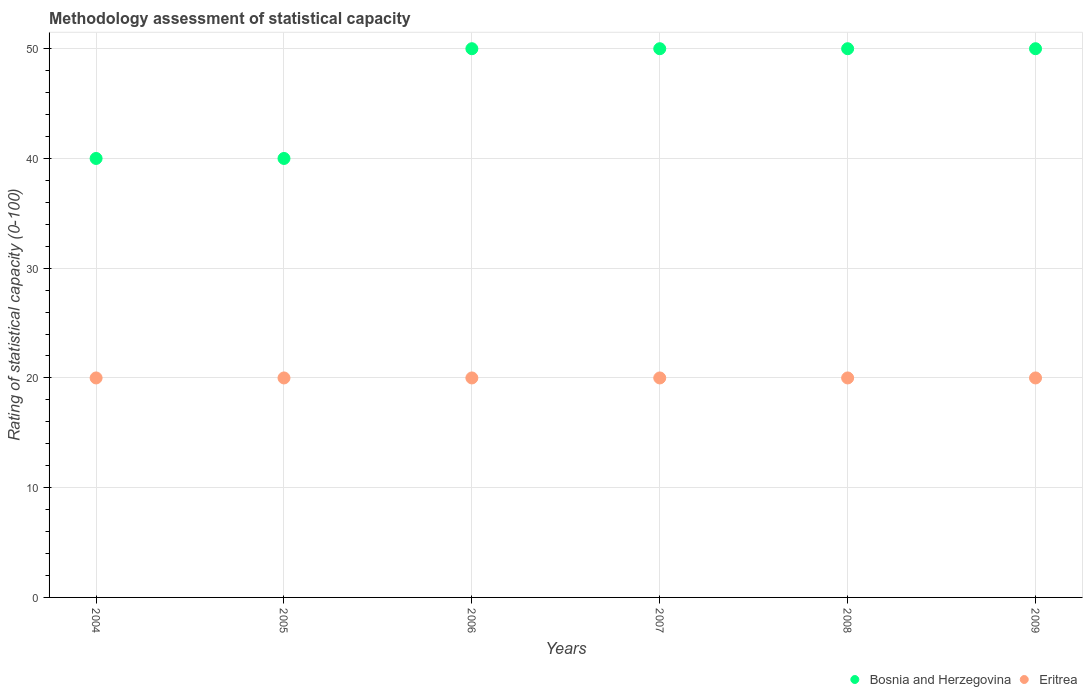How many different coloured dotlines are there?
Make the answer very short. 2. What is the rating of statistical capacity in Bosnia and Herzegovina in 2008?
Your response must be concise. 50. Across all years, what is the maximum rating of statistical capacity in Bosnia and Herzegovina?
Keep it short and to the point. 50. Across all years, what is the minimum rating of statistical capacity in Eritrea?
Provide a succinct answer. 20. In which year was the rating of statistical capacity in Bosnia and Herzegovina maximum?
Provide a short and direct response. 2006. What is the total rating of statistical capacity in Eritrea in the graph?
Offer a very short reply. 120. What is the difference between the rating of statistical capacity in Bosnia and Herzegovina in 2008 and that in 2009?
Offer a terse response. 0. What is the difference between the rating of statistical capacity in Bosnia and Herzegovina in 2004 and the rating of statistical capacity in Eritrea in 2008?
Give a very brief answer. 20. In the year 2004, what is the difference between the rating of statistical capacity in Bosnia and Herzegovina and rating of statistical capacity in Eritrea?
Provide a short and direct response. 20. In how many years, is the rating of statistical capacity in Bosnia and Herzegovina greater than 30?
Provide a succinct answer. 6. What is the ratio of the rating of statistical capacity in Eritrea in 2006 to that in 2008?
Provide a succinct answer. 1. Is the rating of statistical capacity in Eritrea in 2005 less than that in 2008?
Offer a terse response. No. In how many years, is the rating of statistical capacity in Eritrea greater than the average rating of statistical capacity in Eritrea taken over all years?
Offer a very short reply. 0. Does the rating of statistical capacity in Eritrea monotonically increase over the years?
Provide a succinct answer. No. What is the difference between two consecutive major ticks on the Y-axis?
Offer a very short reply. 10. Does the graph contain any zero values?
Make the answer very short. No. Does the graph contain grids?
Give a very brief answer. Yes. Where does the legend appear in the graph?
Offer a terse response. Bottom right. How many legend labels are there?
Provide a short and direct response. 2. What is the title of the graph?
Your answer should be very brief. Methodology assessment of statistical capacity. What is the label or title of the Y-axis?
Offer a very short reply. Rating of statistical capacity (0-100). What is the Rating of statistical capacity (0-100) in Bosnia and Herzegovina in 2004?
Offer a very short reply. 40. What is the Rating of statistical capacity (0-100) of Eritrea in 2004?
Your response must be concise. 20. What is the Rating of statistical capacity (0-100) in Eritrea in 2005?
Give a very brief answer. 20. What is the Rating of statistical capacity (0-100) of Eritrea in 2006?
Provide a short and direct response. 20. What is the Rating of statistical capacity (0-100) in Eritrea in 2007?
Offer a terse response. 20. What is the Rating of statistical capacity (0-100) of Bosnia and Herzegovina in 2008?
Your answer should be compact. 50. What is the Rating of statistical capacity (0-100) in Eritrea in 2008?
Offer a very short reply. 20. What is the Rating of statistical capacity (0-100) in Eritrea in 2009?
Your answer should be compact. 20. Across all years, what is the maximum Rating of statistical capacity (0-100) in Bosnia and Herzegovina?
Provide a succinct answer. 50. Across all years, what is the minimum Rating of statistical capacity (0-100) of Bosnia and Herzegovina?
Your answer should be very brief. 40. What is the total Rating of statistical capacity (0-100) in Bosnia and Herzegovina in the graph?
Your answer should be compact. 280. What is the total Rating of statistical capacity (0-100) in Eritrea in the graph?
Make the answer very short. 120. What is the difference between the Rating of statistical capacity (0-100) in Bosnia and Herzegovina in 2004 and that in 2005?
Ensure brevity in your answer.  0. What is the difference between the Rating of statistical capacity (0-100) of Eritrea in 2004 and that in 2006?
Provide a succinct answer. 0. What is the difference between the Rating of statistical capacity (0-100) of Bosnia and Herzegovina in 2004 and that in 2007?
Provide a succinct answer. -10. What is the difference between the Rating of statistical capacity (0-100) of Bosnia and Herzegovina in 2004 and that in 2008?
Provide a succinct answer. -10. What is the difference between the Rating of statistical capacity (0-100) of Eritrea in 2004 and that in 2008?
Provide a succinct answer. 0. What is the difference between the Rating of statistical capacity (0-100) of Bosnia and Herzegovina in 2004 and that in 2009?
Provide a short and direct response. -10. What is the difference between the Rating of statistical capacity (0-100) of Eritrea in 2005 and that in 2006?
Your response must be concise. 0. What is the difference between the Rating of statistical capacity (0-100) in Eritrea in 2005 and that in 2007?
Keep it short and to the point. 0. What is the difference between the Rating of statistical capacity (0-100) of Bosnia and Herzegovina in 2005 and that in 2008?
Keep it short and to the point. -10. What is the difference between the Rating of statistical capacity (0-100) of Bosnia and Herzegovina in 2006 and that in 2007?
Provide a succinct answer. 0. What is the difference between the Rating of statistical capacity (0-100) of Eritrea in 2006 and that in 2007?
Make the answer very short. 0. What is the difference between the Rating of statistical capacity (0-100) of Bosnia and Herzegovina in 2006 and that in 2008?
Make the answer very short. 0. What is the difference between the Rating of statistical capacity (0-100) in Eritrea in 2006 and that in 2008?
Offer a very short reply. 0. What is the difference between the Rating of statistical capacity (0-100) in Bosnia and Herzegovina in 2006 and that in 2009?
Give a very brief answer. 0. What is the difference between the Rating of statistical capacity (0-100) in Eritrea in 2006 and that in 2009?
Provide a succinct answer. 0. What is the difference between the Rating of statistical capacity (0-100) in Bosnia and Herzegovina in 2007 and that in 2008?
Your answer should be very brief. 0. What is the difference between the Rating of statistical capacity (0-100) in Eritrea in 2007 and that in 2008?
Your answer should be compact. 0. What is the difference between the Rating of statistical capacity (0-100) in Eritrea in 2007 and that in 2009?
Offer a terse response. 0. What is the difference between the Rating of statistical capacity (0-100) in Bosnia and Herzegovina in 2004 and the Rating of statistical capacity (0-100) in Eritrea in 2006?
Make the answer very short. 20. What is the difference between the Rating of statistical capacity (0-100) of Bosnia and Herzegovina in 2004 and the Rating of statistical capacity (0-100) of Eritrea in 2008?
Your response must be concise. 20. What is the difference between the Rating of statistical capacity (0-100) in Bosnia and Herzegovina in 2005 and the Rating of statistical capacity (0-100) in Eritrea in 2006?
Offer a terse response. 20. What is the difference between the Rating of statistical capacity (0-100) of Bosnia and Herzegovina in 2005 and the Rating of statistical capacity (0-100) of Eritrea in 2008?
Offer a very short reply. 20. What is the difference between the Rating of statistical capacity (0-100) of Bosnia and Herzegovina in 2006 and the Rating of statistical capacity (0-100) of Eritrea in 2009?
Provide a succinct answer. 30. What is the difference between the Rating of statistical capacity (0-100) in Bosnia and Herzegovina in 2008 and the Rating of statistical capacity (0-100) in Eritrea in 2009?
Give a very brief answer. 30. What is the average Rating of statistical capacity (0-100) of Bosnia and Herzegovina per year?
Offer a very short reply. 46.67. What is the average Rating of statistical capacity (0-100) of Eritrea per year?
Your answer should be compact. 20. In the year 2004, what is the difference between the Rating of statistical capacity (0-100) in Bosnia and Herzegovina and Rating of statistical capacity (0-100) in Eritrea?
Make the answer very short. 20. In the year 2005, what is the difference between the Rating of statistical capacity (0-100) in Bosnia and Herzegovina and Rating of statistical capacity (0-100) in Eritrea?
Provide a short and direct response. 20. In the year 2006, what is the difference between the Rating of statistical capacity (0-100) in Bosnia and Herzegovina and Rating of statistical capacity (0-100) in Eritrea?
Keep it short and to the point. 30. In the year 2007, what is the difference between the Rating of statistical capacity (0-100) in Bosnia and Herzegovina and Rating of statistical capacity (0-100) in Eritrea?
Give a very brief answer. 30. In the year 2009, what is the difference between the Rating of statistical capacity (0-100) of Bosnia and Herzegovina and Rating of statistical capacity (0-100) of Eritrea?
Provide a succinct answer. 30. What is the ratio of the Rating of statistical capacity (0-100) in Bosnia and Herzegovina in 2004 to that in 2005?
Your response must be concise. 1. What is the ratio of the Rating of statistical capacity (0-100) of Eritrea in 2004 to that in 2005?
Make the answer very short. 1. What is the ratio of the Rating of statistical capacity (0-100) of Bosnia and Herzegovina in 2004 to that in 2006?
Offer a very short reply. 0.8. What is the ratio of the Rating of statistical capacity (0-100) of Bosnia and Herzegovina in 2004 to that in 2007?
Keep it short and to the point. 0.8. What is the ratio of the Rating of statistical capacity (0-100) of Eritrea in 2004 to that in 2008?
Your answer should be very brief. 1. What is the ratio of the Rating of statistical capacity (0-100) of Bosnia and Herzegovina in 2004 to that in 2009?
Your response must be concise. 0.8. What is the ratio of the Rating of statistical capacity (0-100) of Eritrea in 2005 to that in 2006?
Your response must be concise. 1. What is the ratio of the Rating of statistical capacity (0-100) of Eritrea in 2005 to that in 2008?
Offer a very short reply. 1. What is the ratio of the Rating of statistical capacity (0-100) of Bosnia and Herzegovina in 2006 to that in 2007?
Ensure brevity in your answer.  1. What is the ratio of the Rating of statistical capacity (0-100) in Eritrea in 2006 to that in 2007?
Make the answer very short. 1. What is the ratio of the Rating of statistical capacity (0-100) of Bosnia and Herzegovina in 2006 to that in 2009?
Offer a terse response. 1. What is the ratio of the Rating of statistical capacity (0-100) of Bosnia and Herzegovina in 2008 to that in 2009?
Ensure brevity in your answer.  1. What is the difference between the highest and the second highest Rating of statistical capacity (0-100) in Bosnia and Herzegovina?
Your answer should be very brief. 0. What is the difference between the highest and the lowest Rating of statistical capacity (0-100) of Eritrea?
Your response must be concise. 0. 